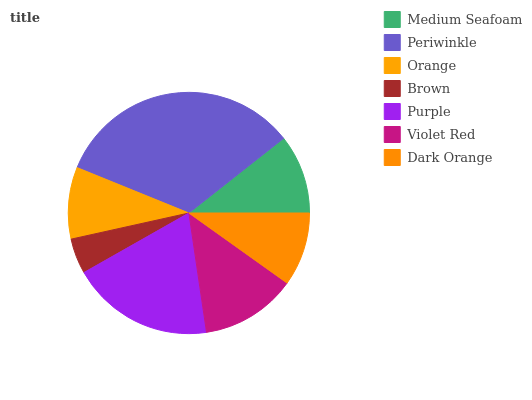Is Brown the minimum?
Answer yes or no. Yes. Is Periwinkle the maximum?
Answer yes or no. Yes. Is Orange the minimum?
Answer yes or no. No. Is Orange the maximum?
Answer yes or no. No. Is Periwinkle greater than Orange?
Answer yes or no. Yes. Is Orange less than Periwinkle?
Answer yes or no. Yes. Is Orange greater than Periwinkle?
Answer yes or no. No. Is Periwinkle less than Orange?
Answer yes or no. No. Is Medium Seafoam the high median?
Answer yes or no. Yes. Is Medium Seafoam the low median?
Answer yes or no. Yes. Is Purple the high median?
Answer yes or no. No. Is Orange the low median?
Answer yes or no. No. 